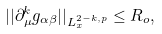<formula> <loc_0><loc_0><loc_500><loc_500>| | \partial _ { \mu } ^ { k } { g } _ { \alpha \beta } | | _ { L _ { x } ^ { 2 - k , p } } \leq R _ { o } ,</formula> 